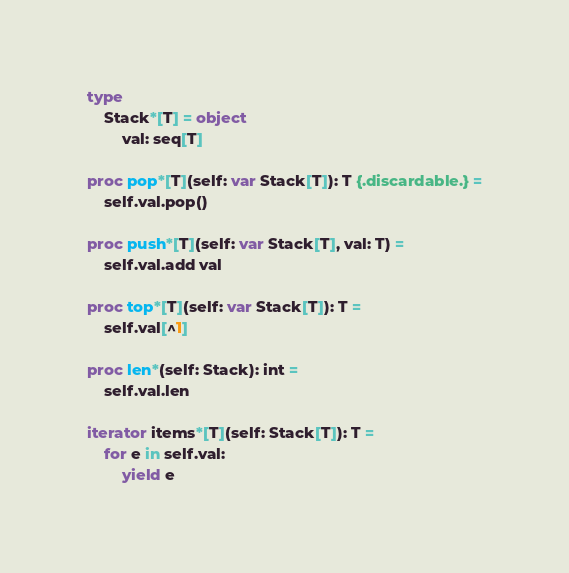<code> <loc_0><loc_0><loc_500><loc_500><_Nim_>
type
    Stack*[T] = object
        val: seq[T]

proc pop*[T](self: var Stack[T]): T {.discardable.} =
    self.val.pop()

proc push*[T](self: var Stack[T], val: T) =
    self.val.add val

proc top*[T](self: var Stack[T]): T =
    self.val[^1]

proc len*(self: Stack): int =
    self.val.len

iterator items*[T](self: Stack[T]): T =
    for e in self.val:
        yield e</code> 